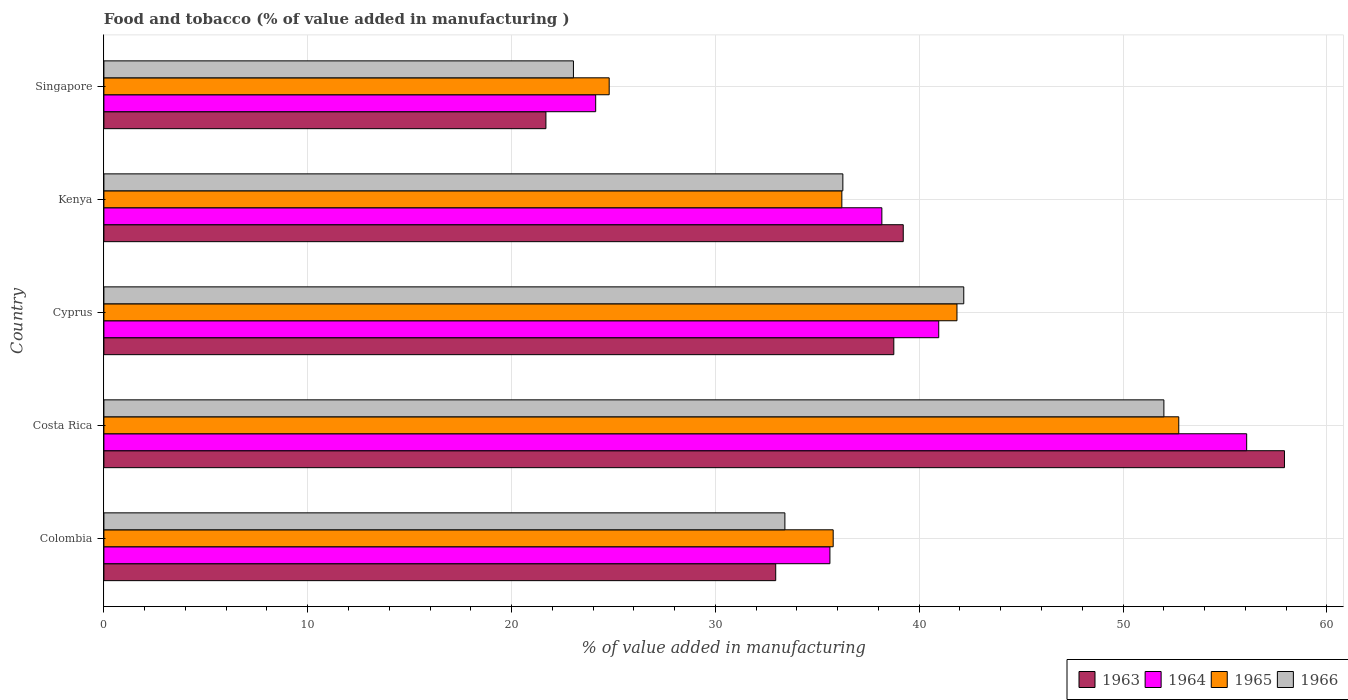Are the number of bars on each tick of the Y-axis equal?
Offer a terse response. Yes. How many bars are there on the 5th tick from the top?
Offer a very short reply. 4. How many bars are there on the 5th tick from the bottom?
Your answer should be very brief. 4. What is the label of the 2nd group of bars from the top?
Your response must be concise. Kenya. What is the value added in manufacturing food and tobacco in 1965 in Colombia?
Your response must be concise. 35.78. Across all countries, what is the maximum value added in manufacturing food and tobacco in 1963?
Offer a terse response. 57.92. Across all countries, what is the minimum value added in manufacturing food and tobacco in 1965?
Provide a short and direct response. 24.79. In which country was the value added in manufacturing food and tobacco in 1966 maximum?
Your response must be concise. Costa Rica. In which country was the value added in manufacturing food and tobacco in 1965 minimum?
Ensure brevity in your answer.  Singapore. What is the total value added in manufacturing food and tobacco in 1966 in the graph?
Provide a succinct answer. 186.89. What is the difference between the value added in manufacturing food and tobacco in 1965 in Colombia and that in Cyprus?
Provide a short and direct response. -6.07. What is the difference between the value added in manufacturing food and tobacco in 1965 in Colombia and the value added in manufacturing food and tobacco in 1966 in Cyprus?
Give a very brief answer. -6.41. What is the average value added in manufacturing food and tobacco in 1966 per country?
Make the answer very short. 37.38. What is the difference between the value added in manufacturing food and tobacco in 1966 and value added in manufacturing food and tobacco in 1964 in Costa Rica?
Your response must be concise. -4.06. In how many countries, is the value added in manufacturing food and tobacco in 1964 greater than 56 %?
Your answer should be compact. 1. What is the ratio of the value added in manufacturing food and tobacco in 1964 in Colombia to that in Kenya?
Keep it short and to the point. 0.93. What is the difference between the highest and the second highest value added in manufacturing food and tobacco in 1963?
Keep it short and to the point. 18.7. What is the difference between the highest and the lowest value added in manufacturing food and tobacco in 1966?
Your answer should be compact. 28.97. In how many countries, is the value added in manufacturing food and tobacco in 1964 greater than the average value added in manufacturing food and tobacco in 1964 taken over all countries?
Provide a succinct answer. 2. Is the sum of the value added in manufacturing food and tobacco in 1965 in Colombia and Cyprus greater than the maximum value added in manufacturing food and tobacco in 1966 across all countries?
Offer a terse response. Yes. Is it the case that in every country, the sum of the value added in manufacturing food and tobacco in 1965 and value added in manufacturing food and tobacco in 1964 is greater than the sum of value added in manufacturing food and tobacco in 1963 and value added in manufacturing food and tobacco in 1966?
Offer a very short reply. No. What does the 3rd bar from the top in Kenya represents?
Ensure brevity in your answer.  1964. What does the 4th bar from the bottom in Singapore represents?
Keep it short and to the point. 1966. Is it the case that in every country, the sum of the value added in manufacturing food and tobacco in 1966 and value added in manufacturing food and tobacco in 1964 is greater than the value added in manufacturing food and tobacco in 1965?
Offer a very short reply. Yes. How many bars are there?
Provide a succinct answer. 20. What is the difference between two consecutive major ticks on the X-axis?
Keep it short and to the point. 10. Does the graph contain grids?
Your answer should be very brief. Yes. How many legend labels are there?
Keep it short and to the point. 4. How are the legend labels stacked?
Ensure brevity in your answer.  Horizontal. What is the title of the graph?
Give a very brief answer. Food and tobacco (% of value added in manufacturing ). Does "1983" appear as one of the legend labels in the graph?
Keep it short and to the point. No. What is the label or title of the X-axis?
Provide a succinct answer. % of value added in manufacturing. What is the % of value added in manufacturing in 1963 in Colombia?
Provide a short and direct response. 32.96. What is the % of value added in manufacturing of 1964 in Colombia?
Make the answer very short. 35.62. What is the % of value added in manufacturing in 1965 in Colombia?
Your answer should be very brief. 35.78. What is the % of value added in manufacturing of 1966 in Colombia?
Offer a very short reply. 33.41. What is the % of value added in manufacturing of 1963 in Costa Rica?
Provide a short and direct response. 57.92. What is the % of value added in manufacturing of 1964 in Costa Rica?
Offer a terse response. 56.07. What is the % of value added in manufacturing in 1965 in Costa Rica?
Give a very brief answer. 52.73. What is the % of value added in manufacturing of 1966 in Costa Rica?
Ensure brevity in your answer.  52. What is the % of value added in manufacturing in 1963 in Cyprus?
Provide a short and direct response. 38.75. What is the % of value added in manufacturing of 1964 in Cyprus?
Keep it short and to the point. 40.96. What is the % of value added in manufacturing in 1965 in Cyprus?
Make the answer very short. 41.85. What is the % of value added in manufacturing of 1966 in Cyprus?
Provide a succinct answer. 42.19. What is the % of value added in manufacturing of 1963 in Kenya?
Provide a succinct answer. 39.22. What is the % of value added in manufacturing of 1964 in Kenya?
Offer a very short reply. 38.17. What is the % of value added in manufacturing of 1965 in Kenya?
Offer a very short reply. 36.2. What is the % of value added in manufacturing in 1966 in Kenya?
Provide a short and direct response. 36.25. What is the % of value added in manufacturing in 1963 in Singapore?
Offer a very short reply. 21.69. What is the % of value added in manufacturing in 1964 in Singapore?
Offer a terse response. 24.13. What is the % of value added in manufacturing of 1965 in Singapore?
Make the answer very short. 24.79. What is the % of value added in manufacturing in 1966 in Singapore?
Make the answer very short. 23.04. Across all countries, what is the maximum % of value added in manufacturing in 1963?
Make the answer very short. 57.92. Across all countries, what is the maximum % of value added in manufacturing in 1964?
Make the answer very short. 56.07. Across all countries, what is the maximum % of value added in manufacturing in 1965?
Make the answer very short. 52.73. Across all countries, what is the maximum % of value added in manufacturing of 1966?
Provide a succinct answer. 52. Across all countries, what is the minimum % of value added in manufacturing in 1963?
Provide a succinct answer. 21.69. Across all countries, what is the minimum % of value added in manufacturing of 1964?
Offer a terse response. 24.13. Across all countries, what is the minimum % of value added in manufacturing of 1965?
Provide a short and direct response. 24.79. Across all countries, what is the minimum % of value added in manufacturing in 1966?
Give a very brief answer. 23.04. What is the total % of value added in manufacturing of 1963 in the graph?
Your answer should be very brief. 190.54. What is the total % of value added in manufacturing of 1964 in the graph?
Offer a terse response. 194.94. What is the total % of value added in manufacturing of 1965 in the graph?
Offer a very short reply. 191.36. What is the total % of value added in manufacturing of 1966 in the graph?
Provide a succinct answer. 186.89. What is the difference between the % of value added in manufacturing in 1963 in Colombia and that in Costa Rica?
Keep it short and to the point. -24.96. What is the difference between the % of value added in manufacturing of 1964 in Colombia and that in Costa Rica?
Your answer should be very brief. -20.45. What is the difference between the % of value added in manufacturing of 1965 in Colombia and that in Costa Rica?
Offer a very short reply. -16.95. What is the difference between the % of value added in manufacturing in 1966 in Colombia and that in Costa Rica?
Offer a very short reply. -18.59. What is the difference between the % of value added in manufacturing in 1963 in Colombia and that in Cyprus?
Make the answer very short. -5.79. What is the difference between the % of value added in manufacturing of 1964 in Colombia and that in Cyprus?
Offer a terse response. -5.34. What is the difference between the % of value added in manufacturing of 1965 in Colombia and that in Cyprus?
Your response must be concise. -6.07. What is the difference between the % of value added in manufacturing of 1966 in Colombia and that in Cyprus?
Offer a very short reply. -8.78. What is the difference between the % of value added in manufacturing in 1963 in Colombia and that in Kenya?
Ensure brevity in your answer.  -6.26. What is the difference between the % of value added in manufacturing of 1964 in Colombia and that in Kenya?
Your answer should be very brief. -2.55. What is the difference between the % of value added in manufacturing of 1965 in Colombia and that in Kenya?
Offer a very short reply. -0.42. What is the difference between the % of value added in manufacturing in 1966 in Colombia and that in Kenya?
Your response must be concise. -2.84. What is the difference between the % of value added in manufacturing of 1963 in Colombia and that in Singapore?
Offer a very short reply. 11.27. What is the difference between the % of value added in manufacturing in 1964 in Colombia and that in Singapore?
Keep it short and to the point. 11.49. What is the difference between the % of value added in manufacturing in 1965 in Colombia and that in Singapore?
Offer a terse response. 10.99. What is the difference between the % of value added in manufacturing in 1966 in Colombia and that in Singapore?
Ensure brevity in your answer.  10.37. What is the difference between the % of value added in manufacturing of 1963 in Costa Rica and that in Cyprus?
Make the answer very short. 19.17. What is the difference between the % of value added in manufacturing of 1964 in Costa Rica and that in Cyprus?
Your response must be concise. 15.11. What is the difference between the % of value added in manufacturing of 1965 in Costa Rica and that in Cyprus?
Give a very brief answer. 10.88. What is the difference between the % of value added in manufacturing in 1966 in Costa Rica and that in Cyprus?
Your answer should be very brief. 9.82. What is the difference between the % of value added in manufacturing in 1963 in Costa Rica and that in Kenya?
Your answer should be compact. 18.7. What is the difference between the % of value added in manufacturing in 1964 in Costa Rica and that in Kenya?
Give a very brief answer. 17.9. What is the difference between the % of value added in manufacturing of 1965 in Costa Rica and that in Kenya?
Your answer should be compact. 16.53. What is the difference between the % of value added in manufacturing in 1966 in Costa Rica and that in Kenya?
Your answer should be compact. 15.75. What is the difference between the % of value added in manufacturing in 1963 in Costa Rica and that in Singapore?
Make the answer very short. 36.23. What is the difference between the % of value added in manufacturing of 1964 in Costa Rica and that in Singapore?
Ensure brevity in your answer.  31.94. What is the difference between the % of value added in manufacturing in 1965 in Costa Rica and that in Singapore?
Make the answer very short. 27.94. What is the difference between the % of value added in manufacturing of 1966 in Costa Rica and that in Singapore?
Ensure brevity in your answer.  28.97. What is the difference between the % of value added in manufacturing in 1963 in Cyprus and that in Kenya?
Ensure brevity in your answer.  -0.46. What is the difference between the % of value added in manufacturing in 1964 in Cyprus and that in Kenya?
Give a very brief answer. 2.79. What is the difference between the % of value added in manufacturing in 1965 in Cyprus and that in Kenya?
Your response must be concise. 5.65. What is the difference between the % of value added in manufacturing in 1966 in Cyprus and that in Kenya?
Your answer should be very brief. 5.93. What is the difference between the % of value added in manufacturing of 1963 in Cyprus and that in Singapore?
Keep it short and to the point. 17.07. What is the difference between the % of value added in manufacturing of 1964 in Cyprus and that in Singapore?
Your answer should be compact. 16.83. What is the difference between the % of value added in manufacturing in 1965 in Cyprus and that in Singapore?
Your response must be concise. 17.06. What is the difference between the % of value added in manufacturing of 1966 in Cyprus and that in Singapore?
Your answer should be very brief. 19.15. What is the difference between the % of value added in manufacturing of 1963 in Kenya and that in Singapore?
Offer a very short reply. 17.53. What is the difference between the % of value added in manufacturing in 1964 in Kenya and that in Singapore?
Provide a succinct answer. 14.04. What is the difference between the % of value added in manufacturing of 1965 in Kenya and that in Singapore?
Your answer should be very brief. 11.41. What is the difference between the % of value added in manufacturing in 1966 in Kenya and that in Singapore?
Your answer should be very brief. 13.22. What is the difference between the % of value added in manufacturing of 1963 in Colombia and the % of value added in manufacturing of 1964 in Costa Rica?
Offer a very short reply. -23.11. What is the difference between the % of value added in manufacturing in 1963 in Colombia and the % of value added in manufacturing in 1965 in Costa Rica?
Your answer should be compact. -19.77. What is the difference between the % of value added in manufacturing of 1963 in Colombia and the % of value added in manufacturing of 1966 in Costa Rica?
Your response must be concise. -19.04. What is the difference between the % of value added in manufacturing of 1964 in Colombia and the % of value added in manufacturing of 1965 in Costa Rica?
Keep it short and to the point. -17.11. What is the difference between the % of value added in manufacturing in 1964 in Colombia and the % of value added in manufacturing in 1966 in Costa Rica?
Give a very brief answer. -16.38. What is the difference between the % of value added in manufacturing in 1965 in Colombia and the % of value added in manufacturing in 1966 in Costa Rica?
Offer a terse response. -16.22. What is the difference between the % of value added in manufacturing of 1963 in Colombia and the % of value added in manufacturing of 1964 in Cyprus?
Keep it short and to the point. -8. What is the difference between the % of value added in manufacturing in 1963 in Colombia and the % of value added in manufacturing in 1965 in Cyprus?
Give a very brief answer. -8.89. What is the difference between the % of value added in manufacturing of 1963 in Colombia and the % of value added in manufacturing of 1966 in Cyprus?
Your response must be concise. -9.23. What is the difference between the % of value added in manufacturing in 1964 in Colombia and the % of value added in manufacturing in 1965 in Cyprus?
Provide a succinct answer. -6.23. What is the difference between the % of value added in manufacturing of 1964 in Colombia and the % of value added in manufacturing of 1966 in Cyprus?
Your response must be concise. -6.57. What is the difference between the % of value added in manufacturing in 1965 in Colombia and the % of value added in manufacturing in 1966 in Cyprus?
Offer a very short reply. -6.41. What is the difference between the % of value added in manufacturing of 1963 in Colombia and the % of value added in manufacturing of 1964 in Kenya?
Your response must be concise. -5.21. What is the difference between the % of value added in manufacturing of 1963 in Colombia and the % of value added in manufacturing of 1965 in Kenya?
Offer a very short reply. -3.24. What is the difference between the % of value added in manufacturing of 1963 in Colombia and the % of value added in manufacturing of 1966 in Kenya?
Provide a succinct answer. -3.29. What is the difference between the % of value added in manufacturing of 1964 in Colombia and the % of value added in manufacturing of 1965 in Kenya?
Keep it short and to the point. -0.58. What is the difference between the % of value added in manufacturing of 1964 in Colombia and the % of value added in manufacturing of 1966 in Kenya?
Keep it short and to the point. -0.63. What is the difference between the % of value added in manufacturing of 1965 in Colombia and the % of value added in manufacturing of 1966 in Kenya?
Offer a very short reply. -0.47. What is the difference between the % of value added in manufacturing in 1963 in Colombia and the % of value added in manufacturing in 1964 in Singapore?
Provide a succinct answer. 8.83. What is the difference between the % of value added in manufacturing in 1963 in Colombia and the % of value added in manufacturing in 1965 in Singapore?
Provide a short and direct response. 8.17. What is the difference between the % of value added in manufacturing of 1963 in Colombia and the % of value added in manufacturing of 1966 in Singapore?
Offer a terse response. 9.92. What is the difference between the % of value added in manufacturing of 1964 in Colombia and the % of value added in manufacturing of 1965 in Singapore?
Ensure brevity in your answer.  10.83. What is the difference between the % of value added in manufacturing of 1964 in Colombia and the % of value added in manufacturing of 1966 in Singapore?
Provide a succinct answer. 12.58. What is the difference between the % of value added in manufacturing in 1965 in Colombia and the % of value added in manufacturing in 1966 in Singapore?
Provide a short and direct response. 12.74. What is the difference between the % of value added in manufacturing of 1963 in Costa Rica and the % of value added in manufacturing of 1964 in Cyprus?
Keep it short and to the point. 16.96. What is the difference between the % of value added in manufacturing in 1963 in Costa Rica and the % of value added in manufacturing in 1965 in Cyprus?
Keep it short and to the point. 16.07. What is the difference between the % of value added in manufacturing of 1963 in Costa Rica and the % of value added in manufacturing of 1966 in Cyprus?
Offer a terse response. 15.73. What is the difference between the % of value added in manufacturing in 1964 in Costa Rica and the % of value added in manufacturing in 1965 in Cyprus?
Ensure brevity in your answer.  14.21. What is the difference between the % of value added in manufacturing of 1964 in Costa Rica and the % of value added in manufacturing of 1966 in Cyprus?
Keep it short and to the point. 13.88. What is the difference between the % of value added in manufacturing of 1965 in Costa Rica and the % of value added in manufacturing of 1966 in Cyprus?
Your answer should be very brief. 10.55. What is the difference between the % of value added in manufacturing in 1963 in Costa Rica and the % of value added in manufacturing in 1964 in Kenya?
Your response must be concise. 19.75. What is the difference between the % of value added in manufacturing in 1963 in Costa Rica and the % of value added in manufacturing in 1965 in Kenya?
Ensure brevity in your answer.  21.72. What is the difference between the % of value added in manufacturing of 1963 in Costa Rica and the % of value added in manufacturing of 1966 in Kenya?
Your answer should be compact. 21.67. What is the difference between the % of value added in manufacturing in 1964 in Costa Rica and the % of value added in manufacturing in 1965 in Kenya?
Ensure brevity in your answer.  19.86. What is the difference between the % of value added in manufacturing of 1964 in Costa Rica and the % of value added in manufacturing of 1966 in Kenya?
Your answer should be very brief. 19.81. What is the difference between the % of value added in manufacturing of 1965 in Costa Rica and the % of value added in manufacturing of 1966 in Kenya?
Offer a terse response. 16.48. What is the difference between the % of value added in manufacturing of 1963 in Costa Rica and the % of value added in manufacturing of 1964 in Singapore?
Your answer should be very brief. 33.79. What is the difference between the % of value added in manufacturing of 1963 in Costa Rica and the % of value added in manufacturing of 1965 in Singapore?
Provide a short and direct response. 33.13. What is the difference between the % of value added in manufacturing in 1963 in Costa Rica and the % of value added in manufacturing in 1966 in Singapore?
Your answer should be very brief. 34.88. What is the difference between the % of value added in manufacturing in 1964 in Costa Rica and the % of value added in manufacturing in 1965 in Singapore?
Your answer should be compact. 31.28. What is the difference between the % of value added in manufacturing in 1964 in Costa Rica and the % of value added in manufacturing in 1966 in Singapore?
Keep it short and to the point. 33.03. What is the difference between the % of value added in manufacturing of 1965 in Costa Rica and the % of value added in manufacturing of 1966 in Singapore?
Keep it short and to the point. 29.7. What is the difference between the % of value added in manufacturing of 1963 in Cyprus and the % of value added in manufacturing of 1964 in Kenya?
Offer a terse response. 0.59. What is the difference between the % of value added in manufacturing of 1963 in Cyprus and the % of value added in manufacturing of 1965 in Kenya?
Ensure brevity in your answer.  2.55. What is the difference between the % of value added in manufacturing in 1963 in Cyprus and the % of value added in manufacturing in 1966 in Kenya?
Keep it short and to the point. 2.5. What is the difference between the % of value added in manufacturing of 1964 in Cyprus and the % of value added in manufacturing of 1965 in Kenya?
Make the answer very short. 4.75. What is the difference between the % of value added in manufacturing in 1964 in Cyprus and the % of value added in manufacturing in 1966 in Kenya?
Give a very brief answer. 4.7. What is the difference between the % of value added in manufacturing of 1965 in Cyprus and the % of value added in manufacturing of 1966 in Kenya?
Offer a very short reply. 5.6. What is the difference between the % of value added in manufacturing of 1963 in Cyprus and the % of value added in manufacturing of 1964 in Singapore?
Your response must be concise. 14.63. What is the difference between the % of value added in manufacturing in 1963 in Cyprus and the % of value added in manufacturing in 1965 in Singapore?
Offer a terse response. 13.96. What is the difference between the % of value added in manufacturing in 1963 in Cyprus and the % of value added in manufacturing in 1966 in Singapore?
Provide a succinct answer. 15.72. What is the difference between the % of value added in manufacturing in 1964 in Cyprus and the % of value added in manufacturing in 1965 in Singapore?
Give a very brief answer. 16.17. What is the difference between the % of value added in manufacturing in 1964 in Cyprus and the % of value added in manufacturing in 1966 in Singapore?
Make the answer very short. 17.92. What is the difference between the % of value added in manufacturing of 1965 in Cyprus and the % of value added in manufacturing of 1966 in Singapore?
Give a very brief answer. 18.82. What is the difference between the % of value added in manufacturing in 1963 in Kenya and the % of value added in manufacturing in 1964 in Singapore?
Ensure brevity in your answer.  15.09. What is the difference between the % of value added in manufacturing in 1963 in Kenya and the % of value added in manufacturing in 1965 in Singapore?
Ensure brevity in your answer.  14.43. What is the difference between the % of value added in manufacturing of 1963 in Kenya and the % of value added in manufacturing of 1966 in Singapore?
Ensure brevity in your answer.  16.18. What is the difference between the % of value added in manufacturing in 1964 in Kenya and the % of value added in manufacturing in 1965 in Singapore?
Provide a succinct answer. 13.38. What is the difference between the % of value added in manufacturing in 1964 in Kenya and the % of value added in manufacturing in 1966 in Singapore?
Make the answer very short. 15.13. What is the difference between the % of value added in manufacturing in 1965 in Kenya and the % of value added in manufacturing in 1966 in Singapore?
Keep it short and to the point. 13.17. What is the average % of value added in manufacturing of 1963 per country?
Offer a very short reply. 38.11. What is the average % of value added in manufacturing of 1964 per country?
Ensure brevity in your answer.  38.99. What is the average % of value added in manufacturing of 1965 per country?
Give a very brief answer. 38.27. What is the average % of value added in manufacturing of 1966 per country?
Give a very brief answer. 37.38. What is the difference between the % of value added in manufacturing in 1963 and % of value added in manufacturing in 1964 in Colombia?
Give a very brief answer. -2.66. What is the difference between the % of value added in manufacturing of 1963 and % of value added in manufacturing of 1965 in Colombia?
Provide a succinct answer. -2.82. What is the difference between the % of value added in manufacturing of 1963 and % of value added in manufacturing of 1966 in Colombia?
Make the answer very short. -0.45. What is the difference between the % of value added in manufacturing in 1964 and % of value added in manufacturing in 1965 in Colombia?
Provide a short and direct response. -0.16. What is the difference between the % of value added in manufacturing of 1964 and % of value added in manufacturing of 1966 in Colombia?
Make the answer very short. 2.21. What is the difference between the % of value added in manufacturing of 1965 and % of value added in manufacturing of 1966 in Colombia?
Ensure brevity in your answer.  2.37. What is the difference between the % of value added in manufacturing of 1963 and % of value added in manufacturing of 1964 in Costa Rica?
Ensure brevity in your answer.  1.85. What is the difference between the % of value added in manufacturing of 1963 and % of value added in manufacturing of 1965 in Costa Rica?
Provide a succinct answer. 5.19. What is the difference between the % of value added in manufacturing in 1963 and % of value added in manufacturing in 1966 in Costa Rica?
Your answer should be compact. 5.92. What is the difference between the % of value added in manufacturing of 1964 and % of value added in manufacturing of 1965 in Costa Rica?
Your answer should be very brief. 3.33. What is the difference between the % of value added in manufacturing in 1964 and % of value added in manufacturing in 1966 in Costa Rica?
Make the answer very short. 4.06. What is the difference between the % of value added in manufacturing in 1965 and % of value added in manufacturing in 1966 in Costa Rica?
Provide a short and direct response. 0.73. What is the difference between the % of value added in manufacturing in 1963 and % of value added in manufacturing in 1964 in Cyprus?
Offer a very short reply. -2.2. What is the difference between the % of value added in manufacturing in 1963 and % of value added in manufacturing in 1965 in Cyprus?
Provide a short and direct response. -3.1. What is the difference between the % of value added in manufacturing in 1963 and % of value added in manufacturing in 1966 in Cyprus?
Offer a very short reply. -3.43. What is the difference between the % of value added in manufacturing of 1964 and % of value added in manufacturing of 1965 in Cyprus?
Your answer should be compact. -0.9. What is the difference between the % of value added in manufacturing of 1964 and % of value added in manufacturing of 1966 in Cyprus?
Provide a short and direct response. -1.23. What is the difference between the % of value added in manufacturing in 1965 and % of value added in manufacturing in 1966 in Cyprus?
Your answer should be very brief. -0.33. What is the difference between the % of value added in manufacturing of 1963 and % of value added in manufacturing of 1964 in Kenya?
Your answer should be compact. 1.05. What is the difference between the % of value added in manufacturing in 1963 and % of value added in manufacturing in 1965 in Kenya?
Your answer should be very brief. 3.01. What is the difference between the % of value added in manufacturing of 1963 and % of value added in manufacturing of 1966 in Kenya?
Ensure brevity in your answer.  2.96. What is the difference between the % of value added in manufacturing in 1964 and % of value added in manufacturing in 1965 in Kenya?
Offer a terse response. 1.96. What is the difference between the % of value added in manufacturing of 1964 and % of value added in manufacturing of 1966 in Kenya?
Give a very brief answer. 1.91. What is the difference between the % of value added in manufacturing in 1963 and % of value added in manufacturing in 1964 in Singapore?
Your answer should be very brief. -2.44. What is the difference between the % of value added in manufacturing in 1963 and % of value added in manufacturing in 1965 in Singapore?
Your answer should be very brief. -3.1. What is the difference between the % of value added in manufacturing in 1963 and % of value added in manufacturing in 1966 in Singapore?
Ensure brevity in your answer.  -1.35. What is the difference between the % of value added in manufacturing in 1964 and % of value added in manufacturing in 1965 in Singapore?
Provide a short and direct response. -0.66. What is the difference between the % of value added in manufacturing of 1964 and % of value added in manufacturing of 1966 in Singapore?
Offer a terse response. 1.09. What is the difference between the % of value added in manufacturing of 1965 and % of value added in manufacturing of 1966 in Singapore?
Your answer should be very brief. 1.75. What is the ratio of the % of value added in manufacturing of 1963 in Colombia to that in Costa Rica?
Offer a very short reply. 0.57. What is the ratio of the % of value added in manufacturing in 1964 in Colombia to that in Costa Rica?
Ensure brevity in your answer.  0.64. What is the ratio of the % of value added in manufacturing of 1965 in Colombia to that in Costa Rica?
Offer a terse response. 0.68. What is the ratio of the % of value added in manufacturing of 1966 in Colombia to that in Costa Rica?
Give a very brief answer. 0.64. What is the ratio of the % of value added in manufacturing in 1963 in Colombia to that in Cyprus?
Offer a terse response. 0.85. What is the ratio of the % of value added in manufacturing in 1964 in Colombia to that in Cyprus?
Give a very brief answer. 0.87. What is the ratio of the % of value added in manufacturing of 1965 in Colombia to that in Cyprus?
Provide a short and direct response. 0.85. What is the ratio of the % of value added in manufacturing of 1966 in Colombia to that in Cyprus?
Your answer should be compact. 0.79. What is the ratio of the % of value added in manufacturing in 1963 in Colombia to that in Kenya?
Provide a succinct answer. 0.84. What is the ratio of the % of value added in manufacturing in 1964 in Colombia to that in Kenya?
Provide a succinct answer. 0.93. What is the ratio of the % of value added in manufacturing in 1965 in Colombia to that in Kenya?
Ensure brevity in your answer.  0.99. What is the ratio of the % of value added in manufacturing in 1966 in Colombia to that in Kenya?
Ensure brevity in your answer.  0.92. What is the ratio of the % of value added in manufacturing in 1963 in Colombia to that in Singapore?
Keep it short and to the point. 1.52. What is the ratio of the % of value added in manufacturing of 1964 in Colombia to that in Singapore?
Make the answer very short. 1.48. What is the ratio of the % of value added in manufacturing in 1965 in Colombia to that in Singapore?
Provide a succinct answer. 1.44. What is the ratio of the % of value added in manufacturing of 1966 in Colombia to that in Singapore?
Provide a succinct answer. 1.45. What is the ratio of the % of value added in manufacturing of 1963 in Costa Rica to that in Cyprus?
Make the answer very short. 1.49. What is the ratio of the % of value added in manufacturing of 1964 in Costa Rica to that in Cyprus?
Give a very brief answer. 1.37. What is the ratio of the % of value added in manufacturing in 1965 in Costa Rica to that in Cyprus?
Your answer should be compact. 1.26. What is the ratio of the % of value added in manufacturing in 1966 in Costa Rica to that in Cyprus?
Keep it short and to the point. 1.23. What is the ratio of the % of value added in manufacturing of 1963 in Costa Rica to that in Kenya?
Provide a succinct answer. 1.48. What is the ratio of the % of value added in manufacturing in 1964 in Costa Rica to that in Kenya?
Make the answer very short. 1.47. What is the ratio of the % of value added in manufacturing in 1965 in Costa Rica to that in Kenya?
Make the answer very short. 1.46. What is the ratio of the % of value added in manufacturing of 1966 in Costa Rica to that in Kenya?
Offer a terse response. 1.43. What is the ratio of the % of value added in manufacturing in 1963 in Costa Rica to that in Singapore?
Offer a terse response. 2.67. What is the ratio of the % of value added in manufacturing of 1964 in Costa Rica to that in Singapore?
Offer a terse response. 2.32. What is the ratio of the % of value added in manufacturing in 1965 in Costa Rica to that in Singapore?
Provide a succinct answer. 2.13. What is the ratio of the % of value added in manufacturing of 1966 in Costa Rica to that in Singapore?
Offer a terse response. 2.26. What is the ratio of the % of value added in manufacturing in 1963 in Cyprus to that in Kenya?
Make the answer very short. 0.99. What is the ratio of the % of value added in manufacturing of 1964 in Cyprus to that in Kenya?
Ensure brevity in your answer.  1.07. What is the ratio of the % of value added in manufacturing in 1965 in Cyprus to that in Kenya?
Offer a very short reply. 1.16. What is the ratio of the % of value added in manufacturing of 1966 in Cyprus to that in Kenya?
Ensure brevity in your answer.  1.16. What is the ratio of the % of value added in manufacturing in 1963 in Cyprus to that in Singapore?
Give a very brief answer. 1.79. What is the ratio of the % of value added in manufacturing of 1964 in Cyprus to that in Singapore?
Keep it short and to the point. 1.7. What is the ratio of the % of value added in manufacturing of 1965 in Cyprus to that in Singapore?
Offer a terse response. 1.69. What is the ratio of the % of value added in manufacturing of 1966 in Cyprus to that in Singapore?
Provide a succinct answer. 1.83. What is the ratio of the % of value added in manufacturing in 1963 in Kenya to that in Singapore?
Your answer should be compact. 1.81. What is the ratio of the % of value added in manufacturing in 1964 in Kenya to that in Singapore?
Your answer should be compact. 1.58. What is the ratio of the % of value added in manufacturing in 1965 in Kenya to that in Singapore?
Your response must be concise. 1.46. What is the ratio of the % of value added in manufacturing of 1966 in Kenya to that in Singapore?
Keep it short and to the point. 1.57. What is the difference between the highest and the second highest % of value added in manufacturing of 1963?
Your response must be concise. 18.7. What is the difference between the highest and the second highest % of value added in manufacturing in 1964?
Ensure brevity in your answer.  15.11. What is the difference between the highest and the second highest % of value added in manufacturing in 1965?
Your answer should be very brief. 10.88. What is the difference between the highest and the second highest % of value added in manufacturing in 1966?
Provide a short and direct response. 9.82. What is the difference between the highest and the lowest % of value added in manufacturing of 1963?
Provide a short and direct response. 36.23. What is the difference between the highest and the lowest % of value added in manufacturing of 1964?
Your response must be concise. 31.94. What is the difference between the highest and the lowest % of value added in manufacturing in 1965?
Offer a very short reply. 27.94. What is the difference between the highest and the lowest % of value added in manufacturing in 1966?
Provide a succinct answer. 28.97. 